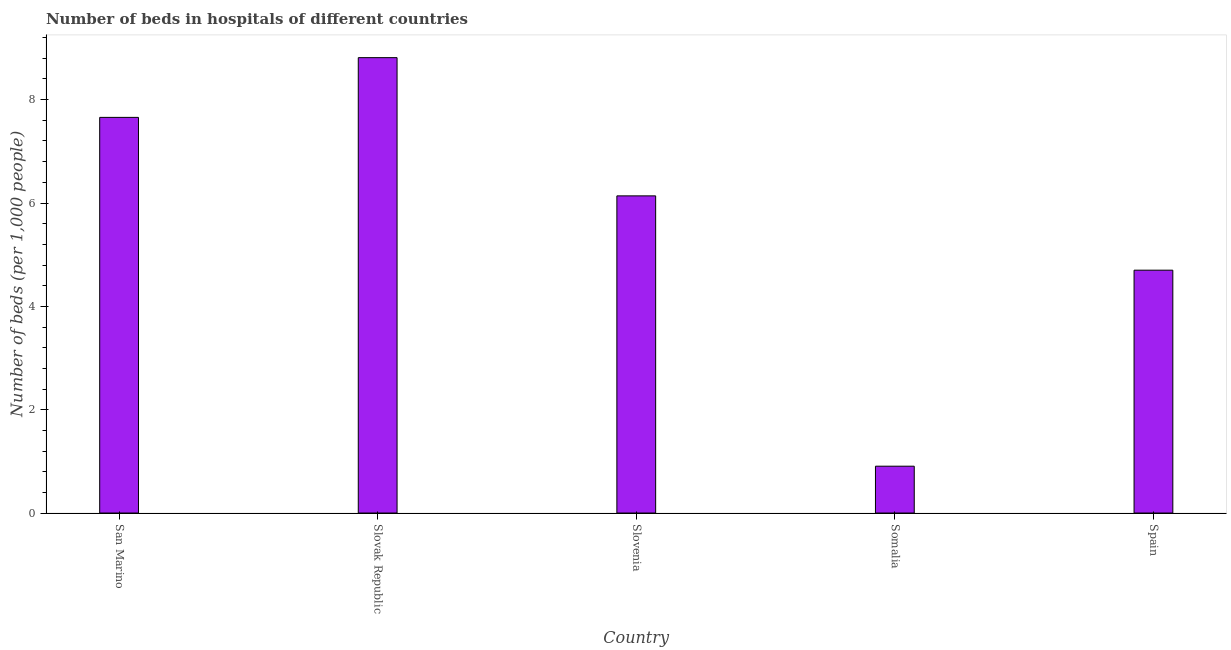Does the graph contain grids?
Provide a succinct answer. No. What is the title of the graph?
Provide a short and direct response. Number of beds in hospitals of different countries. What is the label or title of the Y-axis?
Make the answer very short. Number of beds (per 1,0 people). What is the number of hospital beds in San Marino?
Provide a succinct answer. 7.66. Across all countries, what is the maximum number of hospital beds?
Give a very brief answer. 8.81. Across all countries, what is the minimum number of hospital beds?
Ensure brevity in your answer.  0.91. In which country was the number of hospital beds maximum?
Ensure brevity in your answer.  Slovak Republic. In which country was the number of hospital beds minimum?
Your answer should be very brief. Somalia. What is the sum of the number of hospital beds?
Your answer should be compact. 28.21. What is the difference between the number of hospital beds in Slovenia and Somalia?
Offer a very short reply. 5.23. What is the average number of hospital beds per country?
Your answer should be compact. 5.64. What is the median number of hospital beds?
Your answer should be very brief. 6.14. What is the ratio of the number of hospital beds in Somalia to that in Spain?
Make the answer very short. 0.19. Is the number of hospital beds in San Marino less than that in Spain?
Make the answer very short. No. Is the difference between the number of hospital beds in San Marino and Somalia greater than the difference between any two countries?
Provide a short and direct response. No. What is the difference between the highest and the second highest number of hospital beds?
Offer a terse response. 1.16. What is the difference between the highest and the lowest number of hospital beds?
Keep it short and to the point. 7.91. How many bars are there?
Your response must be concise. 5. How many countries are there in the graph?
Your response must be concise. 5. What is the Number of beds (per 1,000 people) in San Marino?
Provide a short and direct response. 7.66. What is the Number of beds (per 1,000 people) in Slovak Republic?
Make the answer very short. 8.81. What is the Number of beds (per 1,000 people) in Slovenia?
Your answer should be very brief. 6.14. What is the Number of beds (per 1,000 people) in Somalia?
Your response must be concise. 0.91. What is the Number of beds (per 1,000 people) of Spain?
Offer a very short reply. 4.7. What is the difference between the Number of beds (per 1,000 people) in San Marino and Slovak Republic?
Your response must be concise. -1.16. What is the difference between the Number of beds (per 1,000 people) in San Marino and Slovenia?
Make the answer very short. 1.52. What is the difference between the Number of beds (per 1,000 people) in San Marino and Somalia?
Your response must be concise. 6.75. What is the difference between the Number of beds (per 1,000 people) in San Marino and Spain?
Keep it short and to the point. 2.96. What is the difference between the Number of beds (per 1,000 people) in Slovak Republic and Slovenia?
Provide a succinct answer. 2.68. What is the difference between the Number of beds (per 1,000 people) in Slovak Republic and Somalia?
Keep it short and to the point. 7.91. What is the difference between the Number of beds (per 1,000 people) in Slovak Republic and Spain?
Provide a succinct answer. 4.11. What is the difference between the Number of beds (per 1,000 people) in Slovenia and Somalia?
Offer a very short reply. 5.23. What is the difference between the Number of beds (per 1,000 people) in Slovenia and Spain?
Your answer should be compact. 1.44. What is the difference between the Number of beds (per 1,000 people) in Somalia and Spain?
Provide a short and direct response. -3.79. What is the ratio of the Number of beds (per 1,000 people) in San Marino to that in Slovak Republic?
Make the answer very short. 0.87. What is the ratio of the Number of beds (per 1,000 people) in San Marino to that in Slovenia?
Make the answer very short. 1.25. What is the ratio of the Number of beds (per 1,000 people) in San Marino to that in Somalia?
Give a very brief answer. 8.45. What is the ratio of the Number of beds (per 1,000 people) in San Marino to that in Spain?
Keep it short and to the point. 1.63. What is the ratio of the Number of beds (per 1,000 people) in Slovak Republic to that in Slovenia?
Make the answer very short. 1.44. What is the ratio of the Number of beds (per 1,000 people) in Slovak Republic to that in Somalia?
Offer a terse response. 9.72. What is the ratio of the Number of beds (per 1,000 people) in Slovak Republic to that in Spain?
Offer a terse response. 1.88. What is the ratio of the Number of beds (per 1,000 people) in Slovenia to that in Somalia?
Offer a terse response. 6.77. What is the ratio of the Number of beds (per 1,000 people) in Slovenia to that in Spain?
Keep it short and to the point. 1.31. What is the ratio of the Number of beds (per 1,000 people) in Somalia to that in Spain?
Offer a terse response. 0.19. 